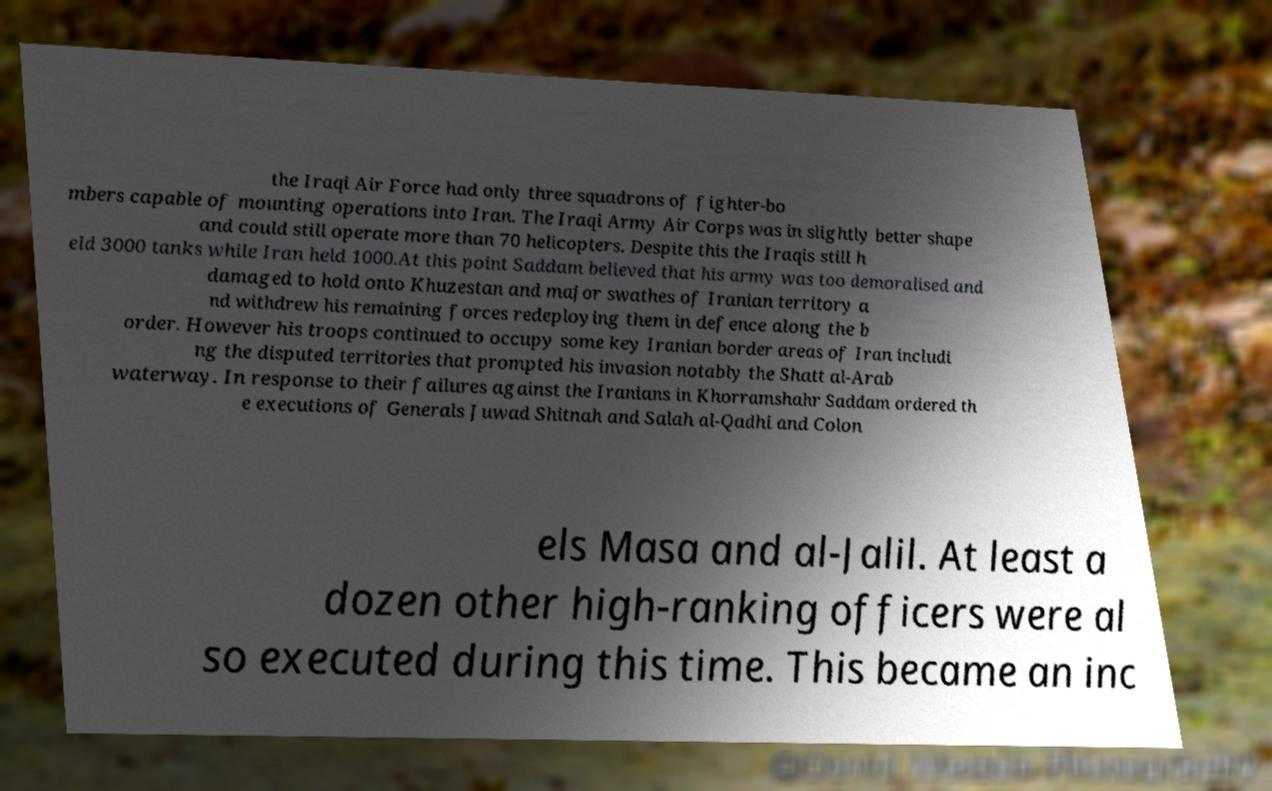There's text embedded in this image that I need extracted. Can you transcribe it verbatim? the Iraqi Air Force had only three squadrons of fighter-bo mbers capable of mounting operations into Iran. The Iraqi Army Air Corps was in slightly better shape and could still operate more than 70 helicopters. Despite this the Iraqis still h eld 3000 tanks while Iran held 1000.At this point Saddam believed that his army was too demoralised and damaged to hold onto Khuzestan and major swathes of Iranian territory a nd withdrew his remaining forces redeploying them in defence along the b order. However his troops continued to occupy some key Iranian border areas of Iran includi ng the disputed territories that prompted his invasion notably the Shatt al-Arab waterway. In response to their failures against the Iranians in Khorramshahr Saddam ordered th e executions of Generals Juwad Shitnah and Salah al-Qadhi and Colon els Masa and al-Jalil. At least a dozen other high-ranking officers were al so executed during this time. This became an inc 